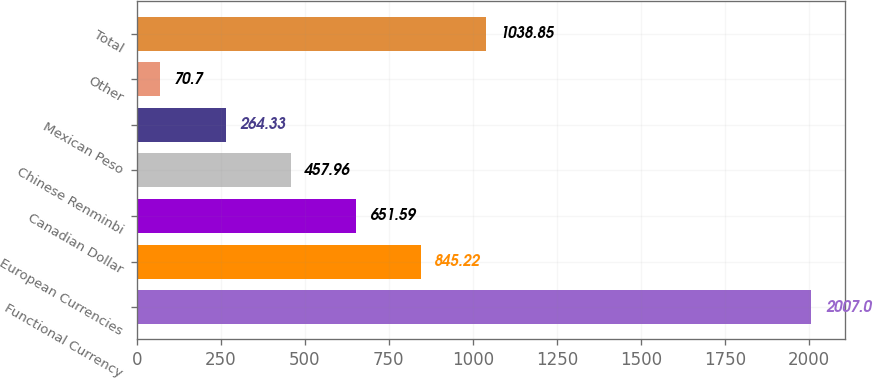Convert chart. <chart><loc_0><loc_0><loc_500><loc_500><bar_chart><fcel>Functional Currency<fcel>European Currencies<fcel>Canadian Dollar<fcel>Chinese Renminbi<fcel>Mexican Peso<fcel>Other<fcel>Total<nl><fcel>2007<fcel>845.22<fcel>651.59<fcel>457.96<fcel>264.33<fcel>70.7<fcel>1038.85<nl></chart> 